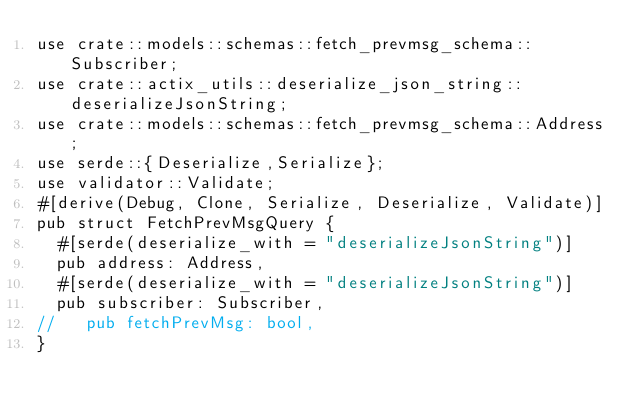Convert code to text. <code><loc_0><loc_0><loc_500><loc_500><_Rust_>use crate::models::schemas::fetch_prevmsg_schema::Subscriber;
use crate::actix_utils::deserialize_json_string::deserializeJsonString;
use crate::models::schemas::fetch_prevmsg_schema::Address;
use serde::{Deserialize,Serialize};
use validator::Validate;
#[derive(Debug, Clone, Serialize, Deserialize, Validate)]
pub struct FetchPrevMsgQuery {
  #[serde(deserialize_with = "deserializeJsonString")]
  pub address: Address,
  #[serde(deserialize_with = "deserializeJsonString")]
  pub subscriber: Subscriber,
//   pub fetchPrevMsg: bool,
}
</code> 